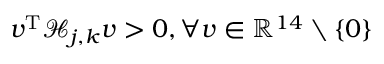<formula> <loc_0><loc_0><loc_500><loc_500>v ^ { T } \mathcal { H } _ { j , k } v > 0 , \forall v \in \mathbb { R } ^ { 1 4 } \ \{ 0 \}</formula> 